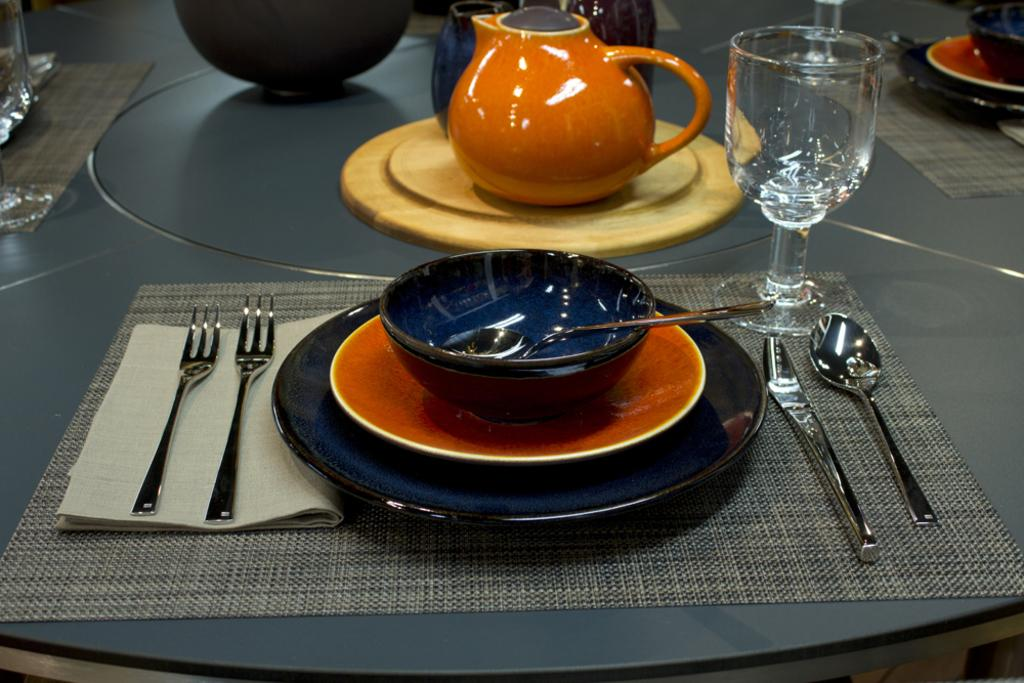What piece of furniture is present in the image? There is a table in the image. What types of utensils can be seen on the table? There are forks, knives, and spoons on the table. What else is on the table besides utensils? There is a plate, a bowl, a teapot, and a glass on the table. How many frogs are sitting on the table in the image? There are no frogs present in the image. What type of weather can be seen in the image? The image does not depict any weather conditions; it only shows a table with various items on it. 